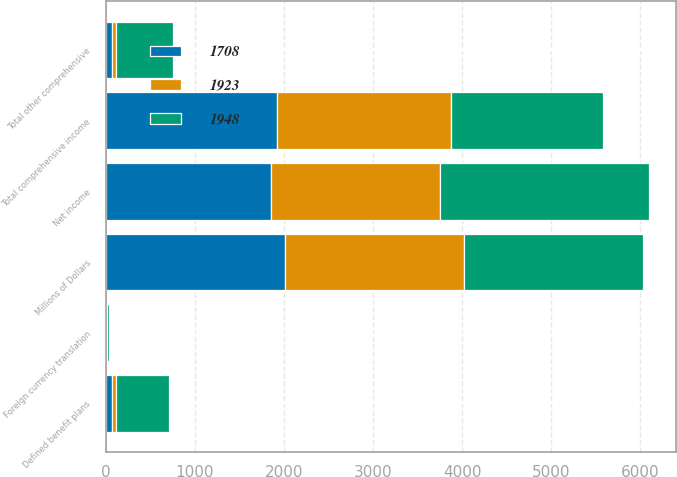<chart> <loc_0><loc_0><loc_500><loc_500><stacked_bar_chart><ecel><fcel>Millions of Dollars<fcel>Net income<fcel>Defined benefit plans<fcel>Foreign currency translation<fcel>Total other comprehensive<fcel>Total comprehensive income<nl><fcel>1923<fcel>2009<fcel>1898<fcel>44<fcel>6<fcel>50<fcel>1948<nl><fcel>1948<fcel>2008<fcel>2338<fcel>604<fcel>26<fcel>630<fcel>1708<nl><fcel>1708<fcel>2007<fcel>1855<fcel>65<fcel>2<fcel>68<fcel>1923<nl></chart> 